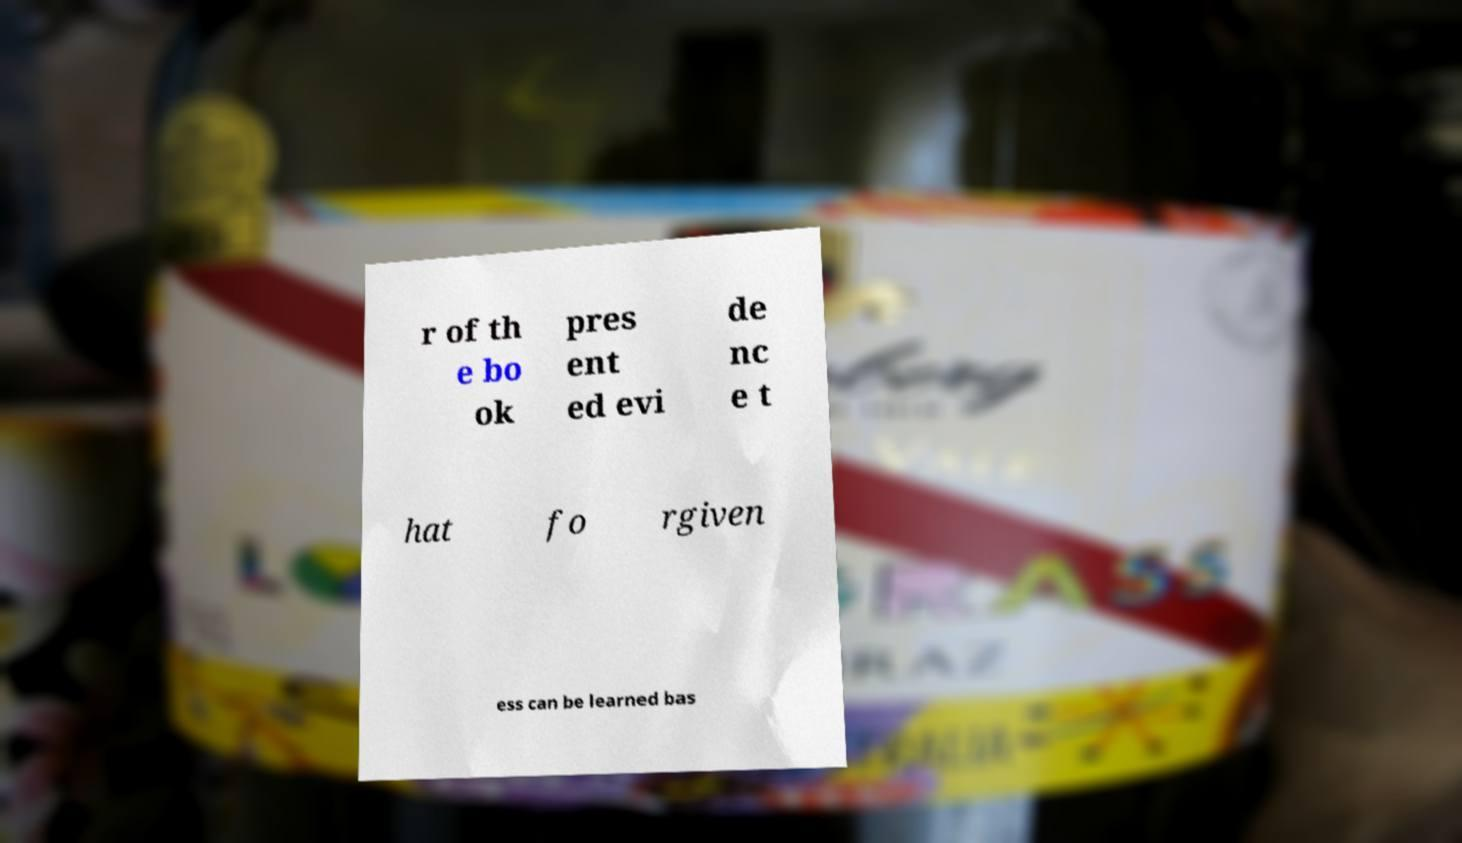Please read and relay the text visible in this image. What does it say? r of th e bo ok pres ent ed evi de nc e t hat fo rgiven ess can be learned bas 